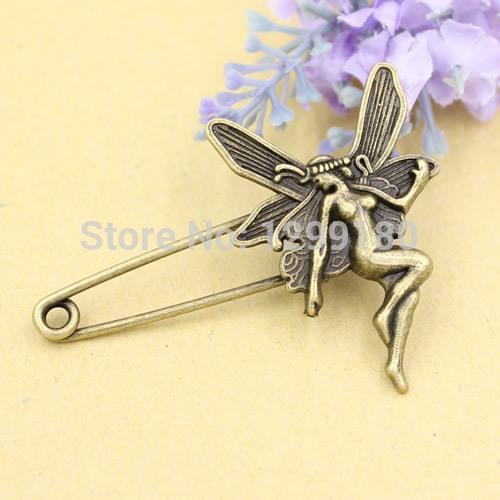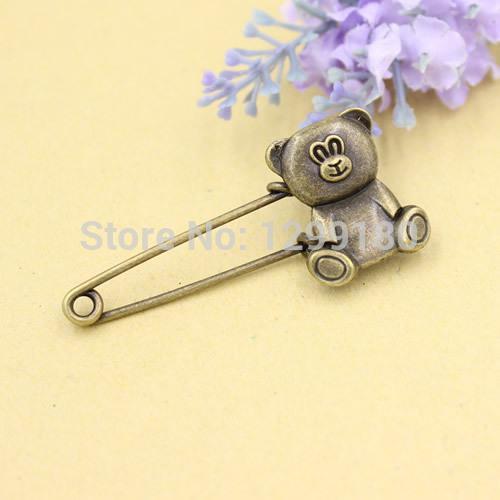The first image is the image on the left, the second image is the image on the right. For the images displayed, is the sentence "There is an animal on one of the clips." factually correct? Answer yes or no. Yes. 